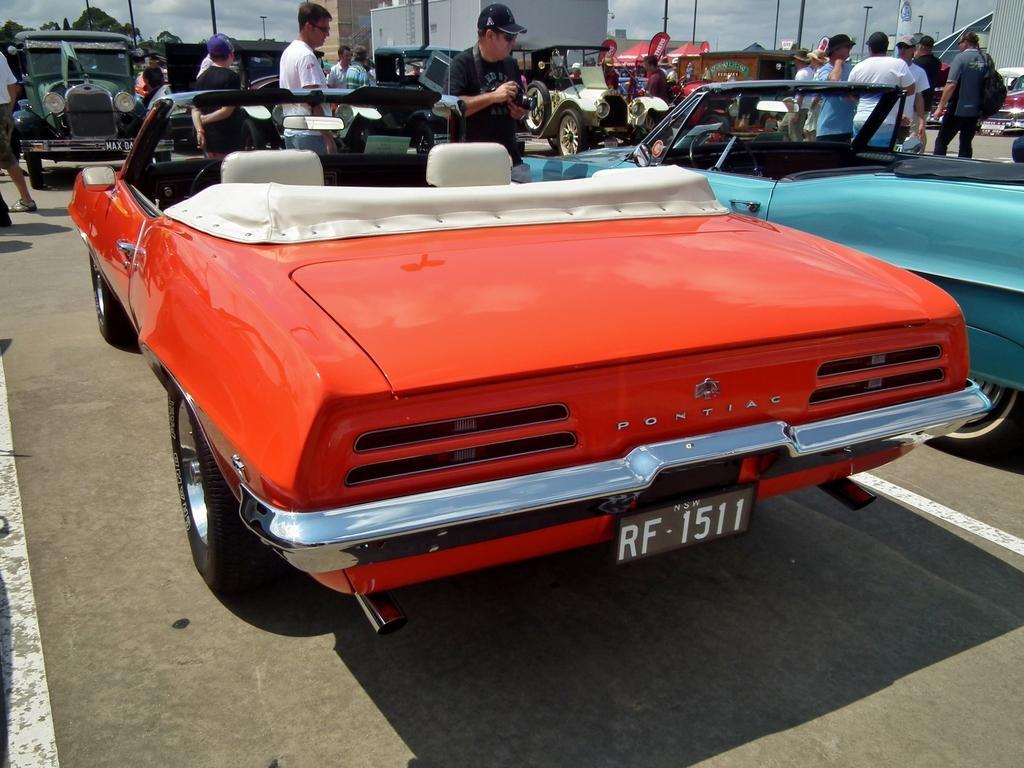How would you summarize this image in a sentence or two? In this picture we can see a group of people, vehicles on the road and in the background we can see poles, trees and the sky. 